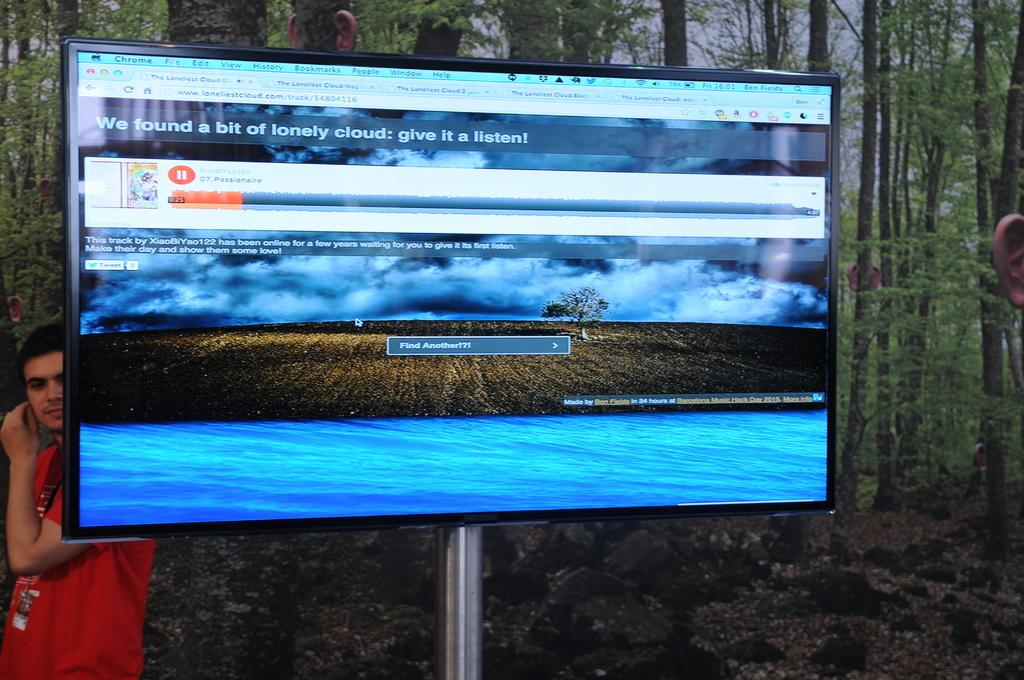<image>
Provide a brief description of the given image. a song on some program called Passionaire playing with someone behind it 